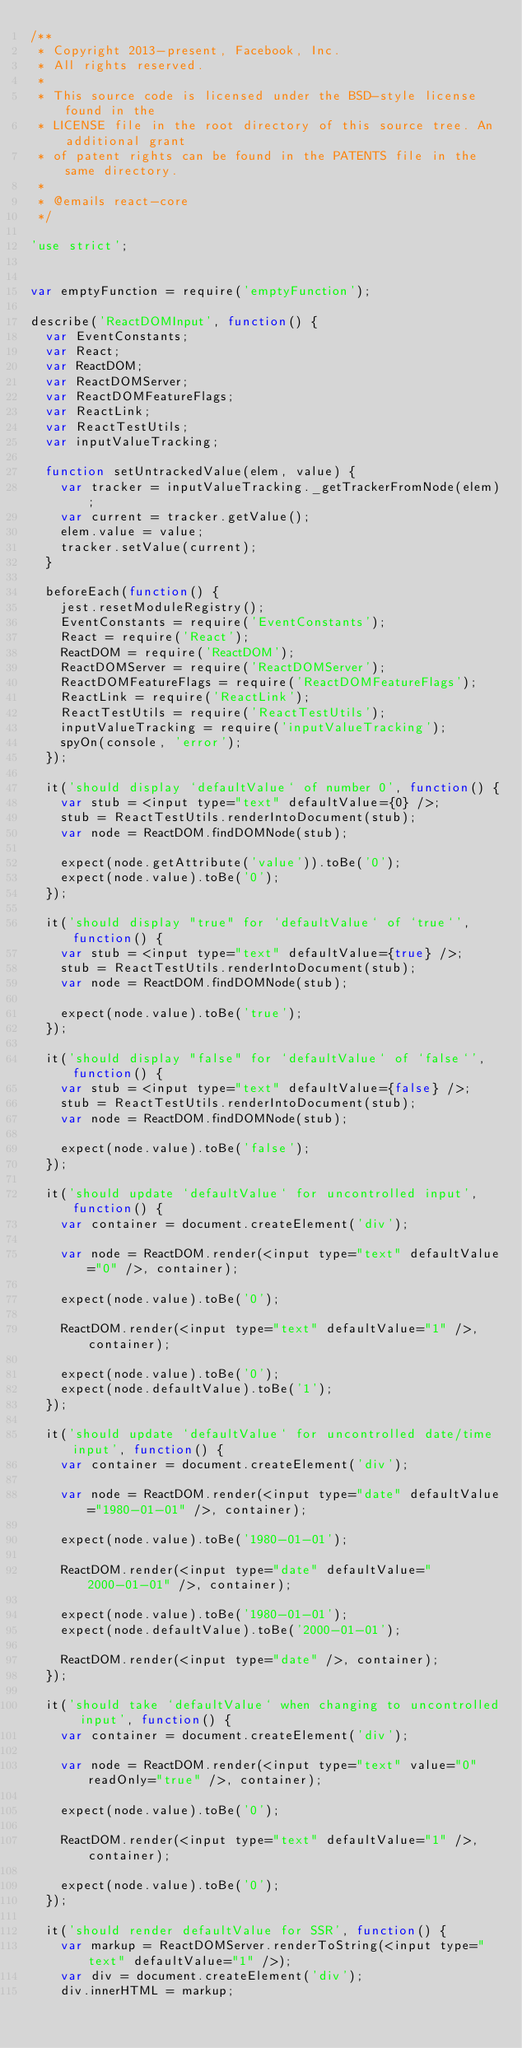Convert code to text. <code><loc_0><loc_0><loc_500><loc_500><_JavaScript_>/**
 * Copyright 2013-present, Facebook, Inc.
 * All rights reserved.
 *
 * This source code is licensed under the BSD-style license found in the
 * LICENSE file in the root directory of this source tree. An additional grant
 * of patent rights can be found in the PATENTS file in the same directory.
 *
 * @emails react-core
 */

'use strict';


var emptyFunction = require('emptyFunction');

describe('ReactDOMInput', function() {
  var EventConstants;
  var React;
  var ReactDOM;
  var ReactDOMServer;
  var ReactDOMFeatureFlags;
  var ReactLink;
  var ReactTestUtils;
  var inputValueTracking;

  function setUntrackedValue(elem, value) {
    var tracker = inputValueTracking._getTrackerFromNode(elem);
    var current = tracker.getValue();
    elem.value = value;
    tracker.setValue(current);
  }

  beforeEach(function() {
    jest.resetModuleRegistry();
    EventConstants = require('EventConstants');
    React = require('React');
    ReactDOM = require('ReactDOM');
    ReactDOMServer = require('ReactDOMServer');
    ReactDOMFeatureFlags = require('ReactDOMFeatureFlags');
    ReactLink = require('ReactLink');
    ReactTestUtils = require('ReactTestUtils');
    inputValueTracking = require('inputValueTracking');
    spyOn(console, 'error');
  });

  it('should display `defaultValue` of number 0', function() {
    var stub = <input type="text" defaultValue={0} />;
    stub = ReactTestUtils.renderIntoDocument(stub);
    var node = ReactDOM.findDOMNode(stub);

    expect(node.getAttribute('value')).toBe('0');
    expect(node.value).toBe('0');
  });

  it('should display "true" for `defaultValue` of `true`', function() {
    var stub = <input type="text" defaultValue={true} />;
    stub = ReactTestUtils.renderIntoDocument(stub);
    var node = ReactDOM.findDOMNode(stub);

    expect(node.value).toBe('true');
  });

  it('should display "false" for `defaultValue` of `false`', function() {
    var stub = <input type="text" defaultValue={false} />;
    stub = ReactTestUtils.renderIntoDocument(stub);
    var node = ReactDOM.findDOMNode(stub);

    expect(node.value).toBe('false');
  });

  it('should update `defaultValue` for uncontrolled input', function() {
    var container = document.createElement('div');

    var node = ReactDOM.render(<input type="text" defaultValue="0" />, container);

    expect(node.value).toBe('0');

    ReactDOM.render(<input type="text" defaultValue="1" />, container);

    expect(node.value).toBe('0');
    expect(node.defaultValue).toBe('1');
  });

  it('should update `defaultValue` for uncontrolled date/time input', function() {
    var container = document.createElement('div');

    var node = ReactDOM.render(<input type="date" defaultValue="1980-01-01" />, container);

    expect(node.value).toBe('1980-01-01');

    ReactDOM.render(<input type="date" defaultValue="2000-01-01" />, container);

    expect(node.value).toBe('1980-01-01');
    expect(node.defaultValue).toBe('2000-01-01');

    ReactDOM.render(<input type="date" />, container);
  });

  it('should take `defaultValue` when changing to uncontrolled input', function() {
    var container = document.createElement('div');

    var node = ReactDOM.render(<input type="text" value="0" readOnly="true" />, container);

    expect(node.value).toBe('0');

    ReactDOM.render(<input type="text" defaultValue="1" />, container);

    expect(node.value).toBe('0');
  });

  it('should render defaultValue for SSR', function() {
    var markup = ReactDOMServer.renderToString(<input type="text" defaultValue="1" />);
    var div = document.createElement('div');
    div.innerHTML = markup;</code> 